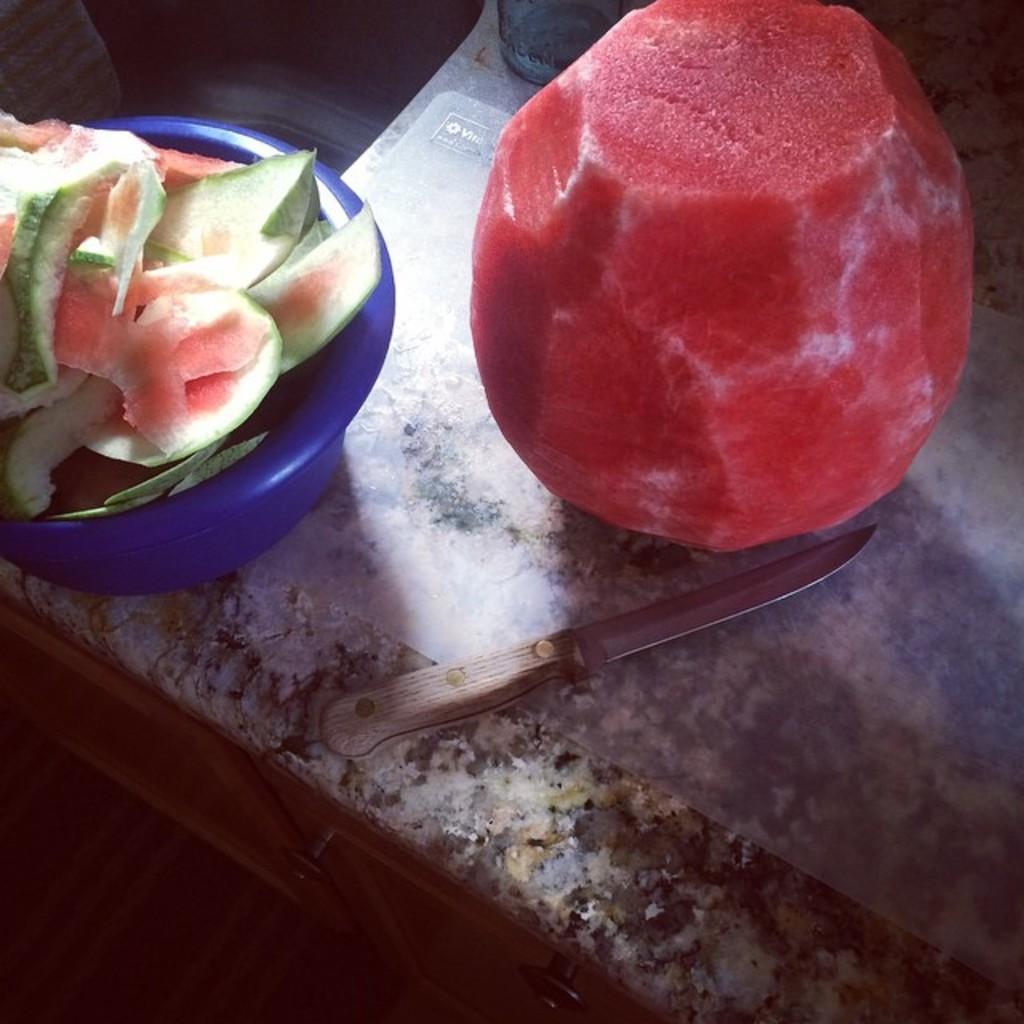In one or two sentences, can you explain what this image depicts? In this image there is a counter table and we can see a knife, bowl, watermelon peels, an object and a watermelon placed on the counter table. 